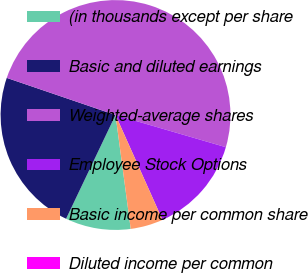Convert chart to OTSL. <chart><loc_0><loc_0><loc_500><loc_500><pie_chart><fcel>(in thousands except per share<fcel>Basic and diluted earnings<fcel>Weighted-average shares<fcel>Employee Stock Options<fcel>Basic income per common share<fcel>Diluted income per common<nl><fcel>9.19%<fcel>23.16%<fcel>49.29%<fcel>13.78%<fcel>4.59%<fcel>0.0%<nl></chart> 